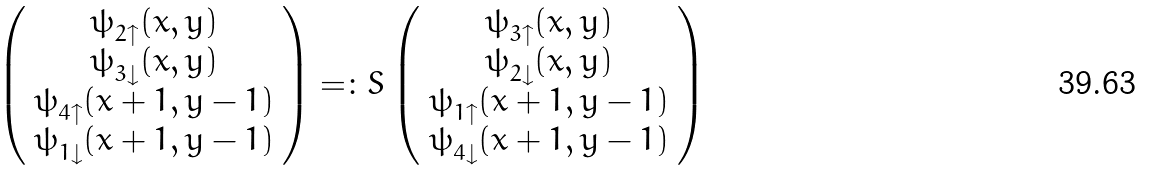<formula> <loc_0><loc_0><loc_500><loc_500>\left ( \begin{array} { c } \psi ^ { \ } _ { 2 \uparrow } ( x , y ) \\ \psi ^ { \ } _ { 3 \downarrow } ( x , y ) \\ \psi ^ { \ } _ { 4 \uparrow } ( x + 1 , y - 1 ) \\ \psi ^ { \ } _ { 1 \downarrow } ( x + 1 , y - 1 ) \\ \end{array} \right ) = \colon S \left ( \begin{array} { c } \psi ^ { \ } _ { 3 \uparrow } ( x , y ) \\ \psi ^ { \ } _ { 2 \downarrow } ( x , y ) \\ \psi ^ { \ } _ { 1 \uparrow } ( x + 1 , y - 1 ) \\ \psi ^ { \ } _ { 4 \downarrow } ( x + 1 , y - 1 ) \\ \end{array} \right )</formula> 